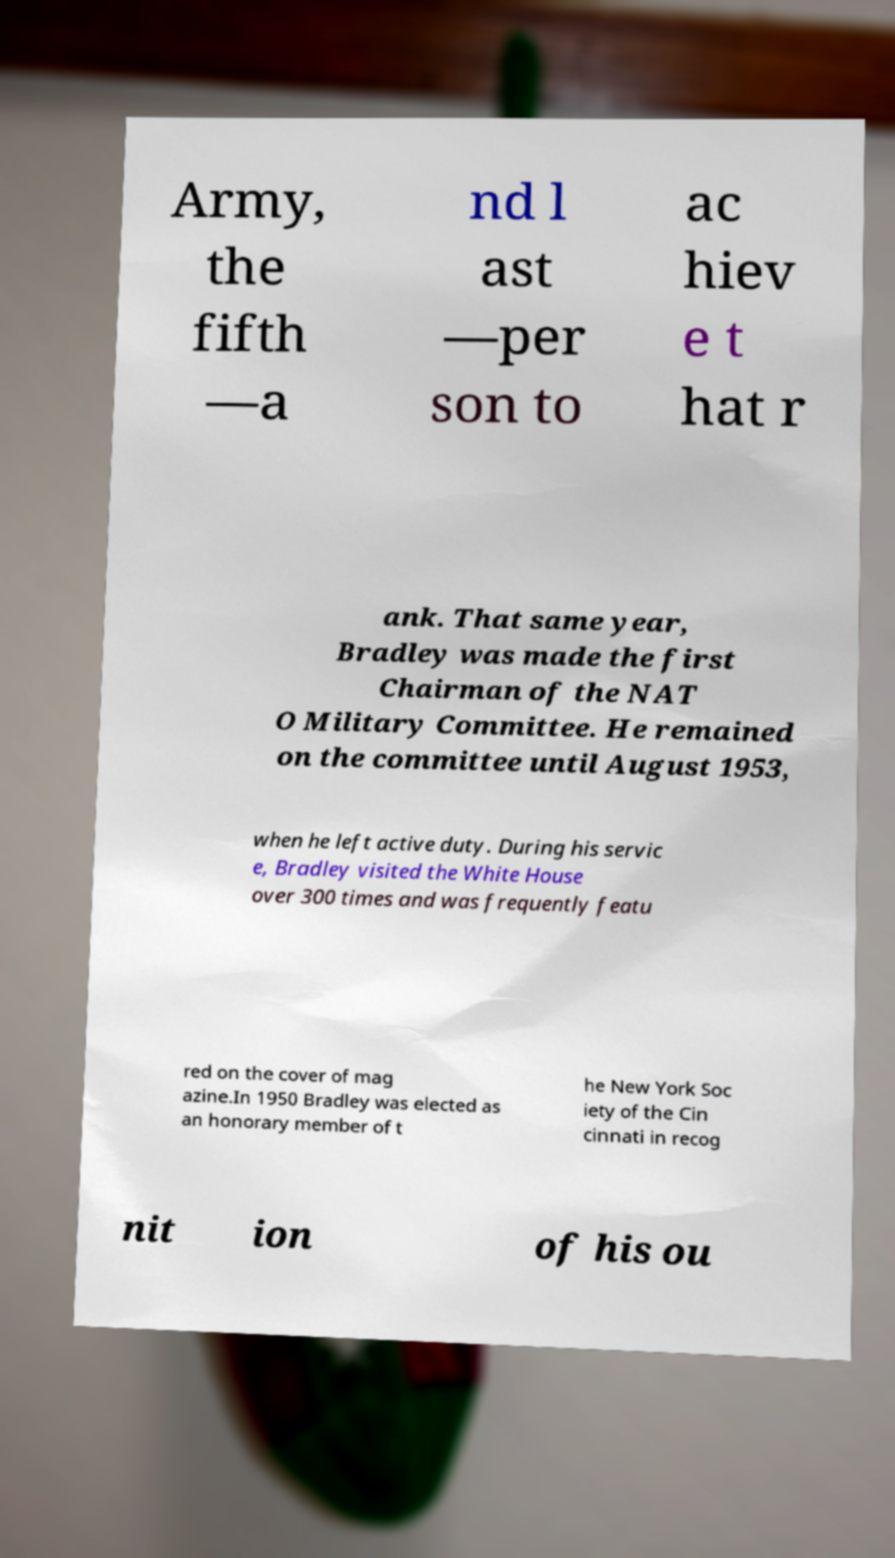What messages or text are displayed in this image? I need them in a readable, typed format. Army, the fifth —a nd l ast —per son to ac hiev e t hat r ank. That same year, Bradley was made the first Chairman of the NAT O Military Committee. He remained on the committee until August 1953, when he left active duty. During his servic e, Bradley visited the White House over 300 times and was frequently featu red on the cover of mag azine.In 1950 Bradley was elected as an honorary member of t he New York Soc iety of the Cin cinnati in recog nit ion of his ou 